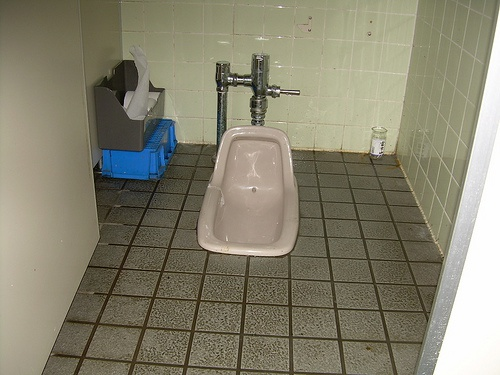Describe the objects in this image and their specific colors. I can see a toilet in gray, darkgray, and tan tones in this image. 